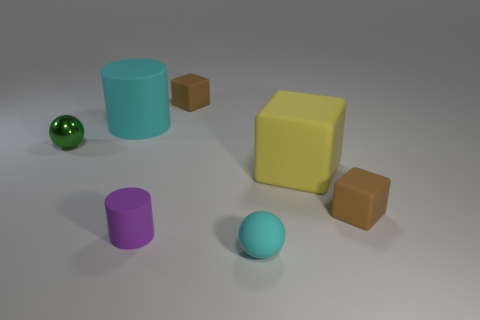What is the shape of the green metallic object?
Give a very brief answer. Sphere. Are there fewer large objects behind the large cyan cylinder than big cyan matte cylinders?
Provide a short and direct response. Yes. Is there a small purple metallic thing of the same shape as the big yellow thing?
Your response must be concise. No. What shape is the purple matte thing that is the same size as the green ball?
Ensure brevity in your answer.  Cylinder. How many things are either tiny green objects or yellow blocks?
Make the answer very short. 2. Are there any big yellow rubber cylinders?
Keep it short and to the point. No. Are there fewer tiny cyan matte things than tiny yellow rubber things?
Your answer should be compact. No. Are there any objects of the same size as the purple cylinder?
Your response must be concise. Yes. There is a tiny purple object; is its shape the same as the small brown object behind the small metal object?
Give a very brief answer. No. How many spheres are either tiny purple rubber things or yellow objects?
Ensure brevity in your answer.  0. 